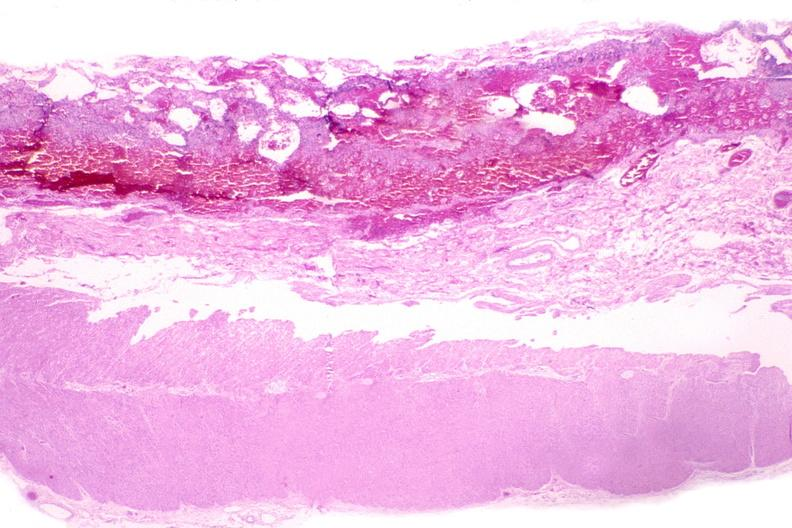s left ventricle hypertrophy present?
Answer the question using a single word or phrase. No 